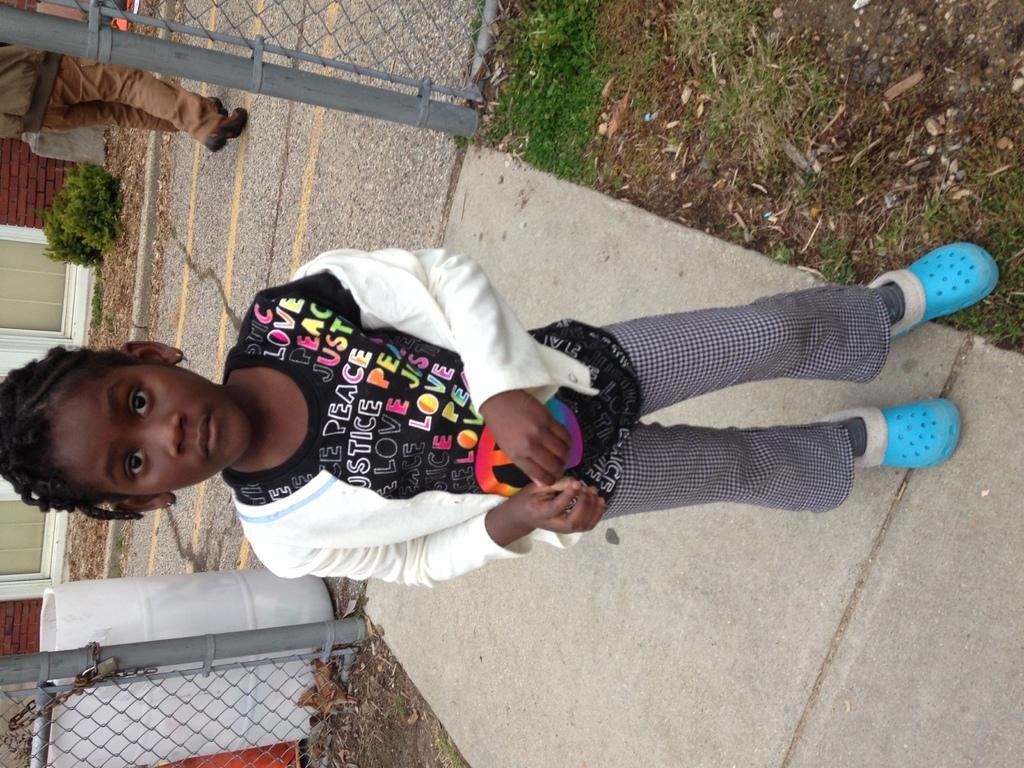What is the main subject of the image? There is a girl standing in the image. Can you describe what the girl is wearing? The girl is wearing clothes and shoes. What is the setting of the image? The setting is a footpath. What type of barrier can be seen in the image? There is a fence in the image. What type of ground surface is visible in the image? Soil and grass are visible in the image. What type of plant is present in the image? There is a plant in the image. What type of container is present in the image? A container is present in the image. What type of wall is visible in the image? A brick wall is visible in the image. Are there any other people in the image besides the girl? Yes, there is a person walking behind the girl. What is the tendency of the pot to fly in the image? There is no pot present in the image, so it is not possible to determine its tendency to fly. 